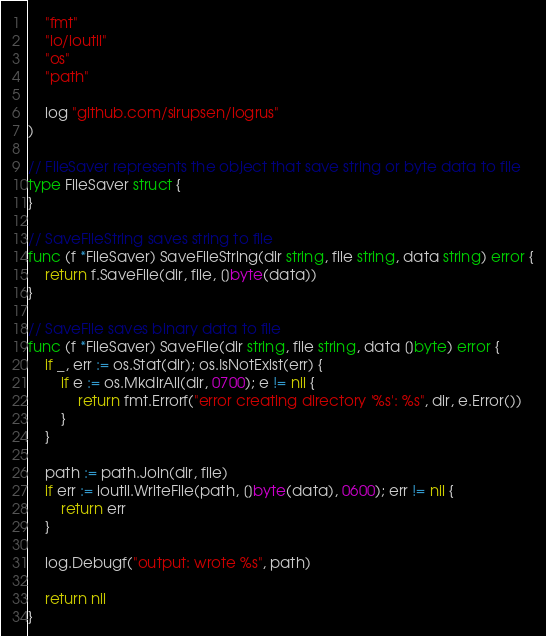Convert code to text. <code><loc_0><loc_0><loc_500><loc_500><_Go_>	"fmt"
	"io/ioutil"
	"os"
	"path"

	log "github.com/sirupsen/logrus"
)

// FileSaver represents the object that save string or byte data to file
type FileSaver struct {
}

// SaveFileString saves string to file
func (f *FileSaver) SaveFileString(dir string, file string, data string) error {
	return f.SaveFile(dir, file, []byte(data))
}

// SaveFile saves binary data to file
func (f *FileSaver) SaveFile(dir string, file string, data []byte) error {
	if _, err := os.Stat(dir); os.IsNotExist(err) {
		if e := os.MkdirAll(dir, 0700); e != nil {
			return fmt.Errorf("error creating directory '%s': %s", dir, e.Error())
		}
	}

	path := path.Join(dir, file)
	if err := ioutil.WriteFile(path, []byte(data), 0600); err != nil {
		return err
	}

	log.Debugf("output: wrote %s", path)

	return nil
}
</code> 